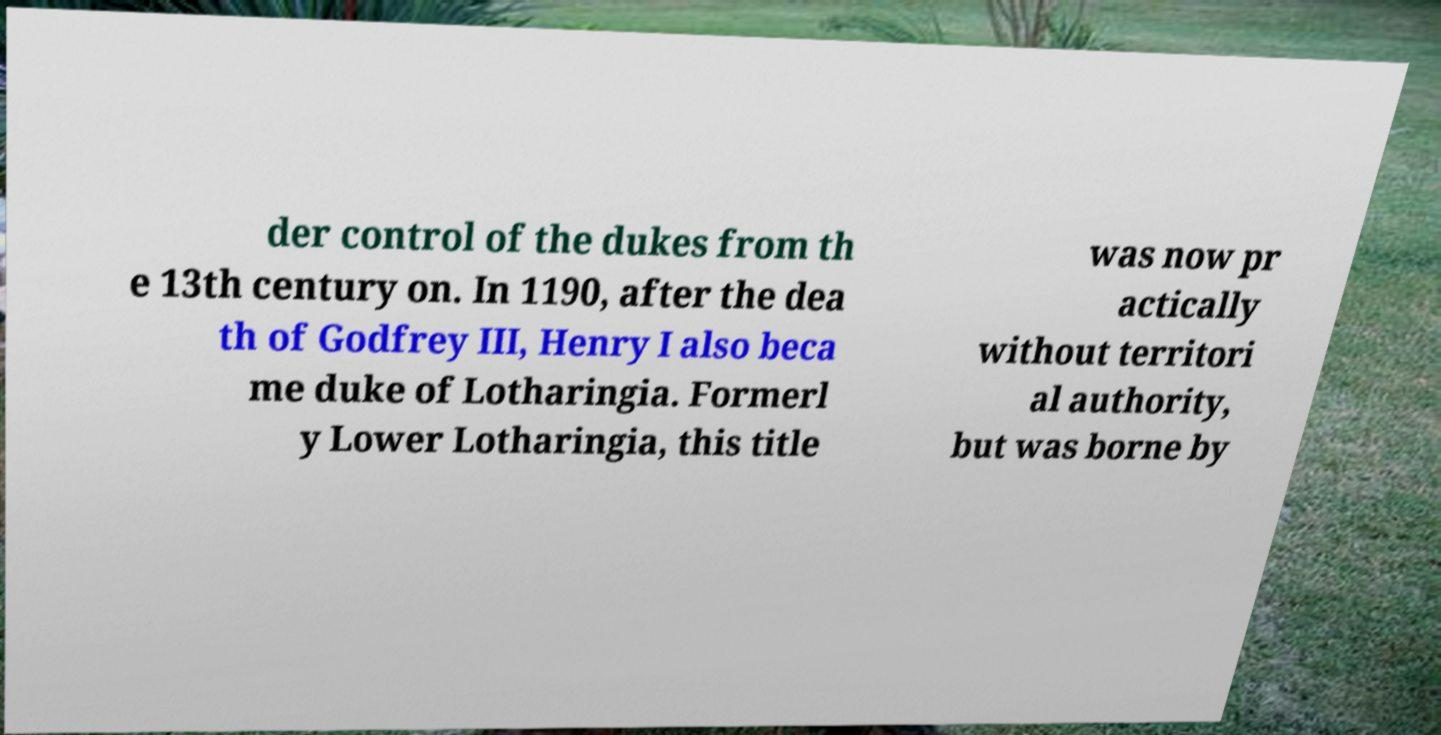For documentation purposes, I need the text within this image transcribed. Could you provide that? der control of the dukes from th e 13th century on. In 1190, after the dea th of Godfrey III, Henry I also beca me duke of Lotharingia. Formerl y Lower Lotharingia, this title was now pr actically without territori al authority, but was borne by 